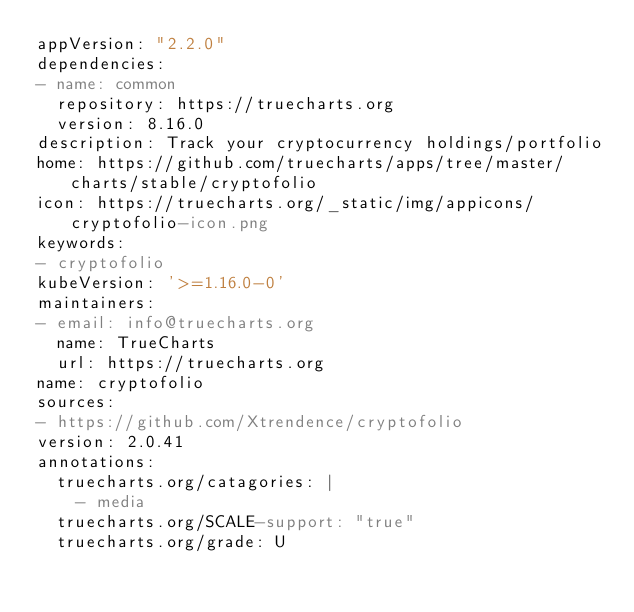<code> <loc_0><loc_0><loc_500><loc_500><_YAML_>appVersion: "2.2.0"
dependencies:
- name: common
  repository: https://truecharts.org
  version: 8.16.0
description: Track your cryptocurrency holdings/portfolio
home: https://github.com/truecharts/apps/tree/master/charts/stable/cryptofolio
icon: https://truecharts.org/_static/img/appicons/cryptofolio-icon.png
keywords:
- cryptofolio
kubeVersion: '>=1.16.0-0'
maintainers:
- email: info@truecharts.org
  name: TrueCharts
  url: https://truecharts.org
name: cryptofolio
sources:
- https://github.com/Xtrendence/cryptofolio
version: 2.0.41
annotations:
  truecharts.org/catagories: |
    - media
  truecharts.org/SCALE-support: "true"
  truecharts.org/grade: U
</code> 